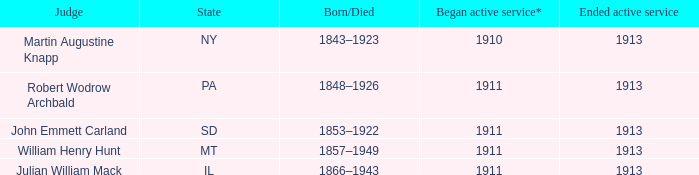Who was the judge for the state SD? John Emmett Carland. 